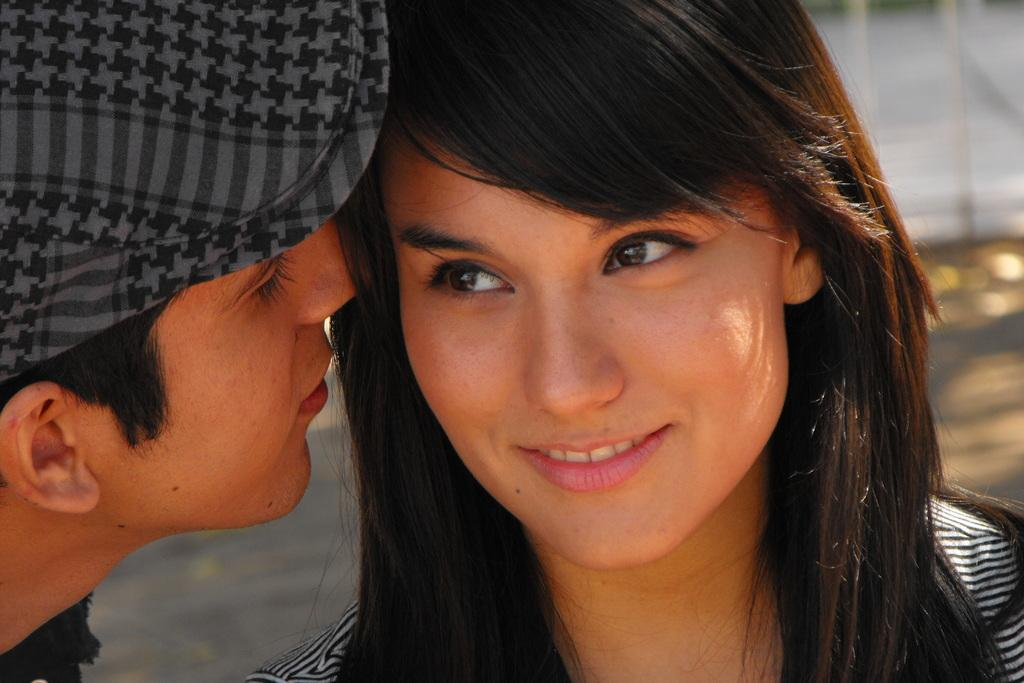What is happening between the guy and the woman in the image? The guy is whispering in the ears of a woman in the image. How many people are present in the image? There are two people in the image, a guy and a woman. What type of pickle is the woman holding in the image? There is no pickle present in the image; the woman is not holding anything. Can you tell me where the cactus is located in the image? There is no cactus present in the image. 